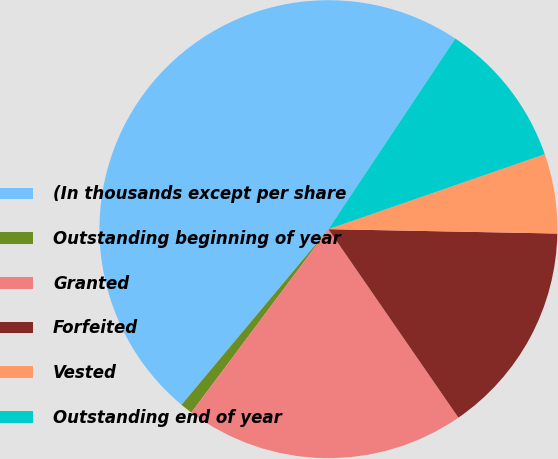Convert chart. <chart><loc_0><loc_0><loc_500><loc_500><pie_chart><fcel>(In thousands except per share<fcel>Outstanding beginning of year<fcel>Granted<fcel>Forfeited<fcel>Vested<fcel>Outstanding end of year<nl><fcel>48.27%<fcel>0.87%<fcel>19.83%<fcel>15.09%<fcel>5.61%<fcel>10.35%<nl></chart> 